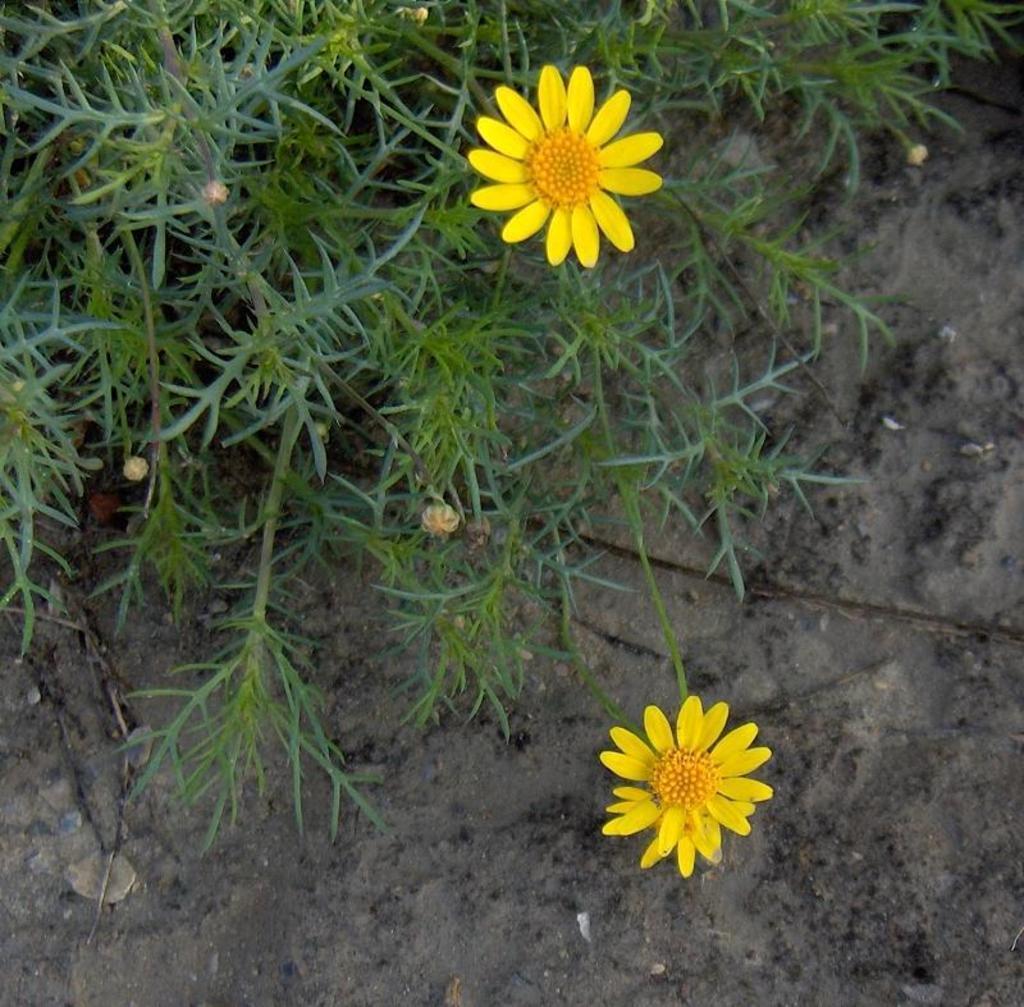Describe this image in one or two sentences. In this image, we can see some flowers on plants and we can also see the ground. 